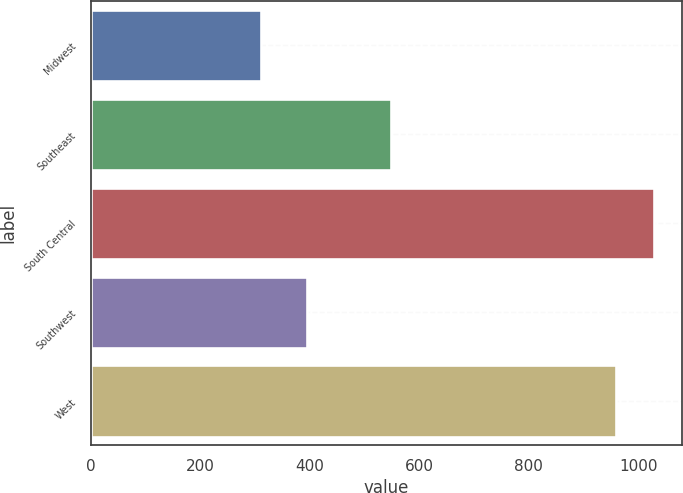<chart> <loc_0><loc_0><loc_500><loc_500><bar_chart><fcel>Midwest<fcel>Southeast<fcel>South Central<fcel>Southwest<fcel>West<nl><fcel>310<fcel>547.5<fcel>1028.67<fcel>394.2<fcel>958.9<nl></chart> 